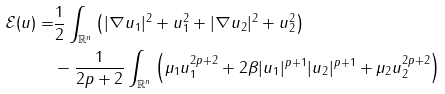<formula> <loc_0><loc_0><loc_500><loc_500>\mathcal { E } ( { u } ) = & \frac { 1 } { 2 } \int _ { \mathbb { R } ^ { n } } \left ( | \nabla u _ { 1 } | ^ { 2 } + u _ { 1 } ^ { 2 } + | \nabla u _ { 2 } | ^ { 2 } + u _ { 2 } ^ { 2 } \right ) \\ & - \frac { 1 } { 2 p + 2 } \int _ { \mathbb { R } ^ { n } } \left ( \mu _ { 1 } u _ { 1 } ^ { 2 p + 2 } + 2 \beta | u _ { 1 } | ^ { p + 1 } | u _ { 2 } | ^ { p + 1 } + \mu _ { 2 } u _ { 2 } ^ { 2 p + 2 } \right )</formula> 